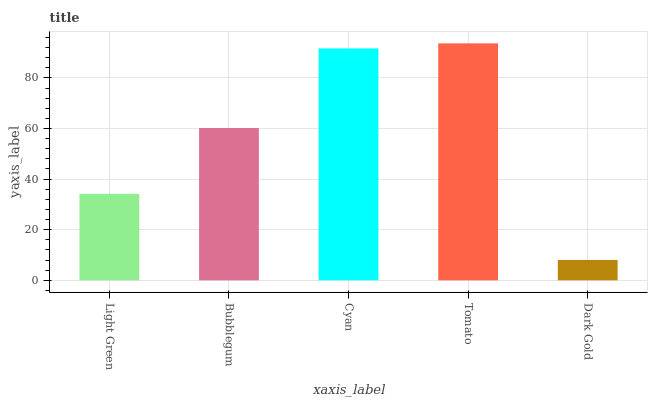Is Dark Gold the minimum?
Answer yes or no. Yes. Is Tomato the maximum?
Answer yes or no. Yes. Is Bubblegum the minimum?
Answer yes or no. No. Is Bubblegum the maximum?
Answer yes or no. No. Is Bubblegum greater than Light Green?
Answer yes or no. Yes. Is Light Green less than Bubblegum?
Answer yes or no. Yes. Is Light Green greater than Bubblegum?
Answer yes or no. No. Is Bubblegum less than Light Green?
Answer yes or no. No. Is Bubblegum the high median?
Answer yes or no. Yes. Is Bubblegum the low median?
Answer yes or no. Yes. Is Light Green the high median?
Answer yes or no. No. Is Cyan the low median?
Answer yes or no. No. 